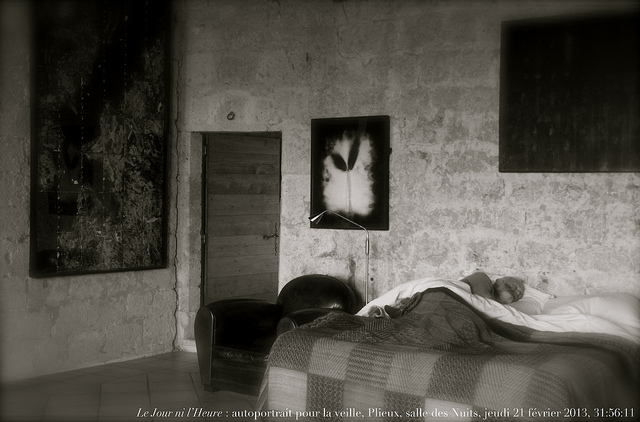Identify the text displayed in this image. 2013 fevrier 21 jeudi Nuits 11 56 31 des salle pLieux veille pour autoportrail l'Heure Jour 